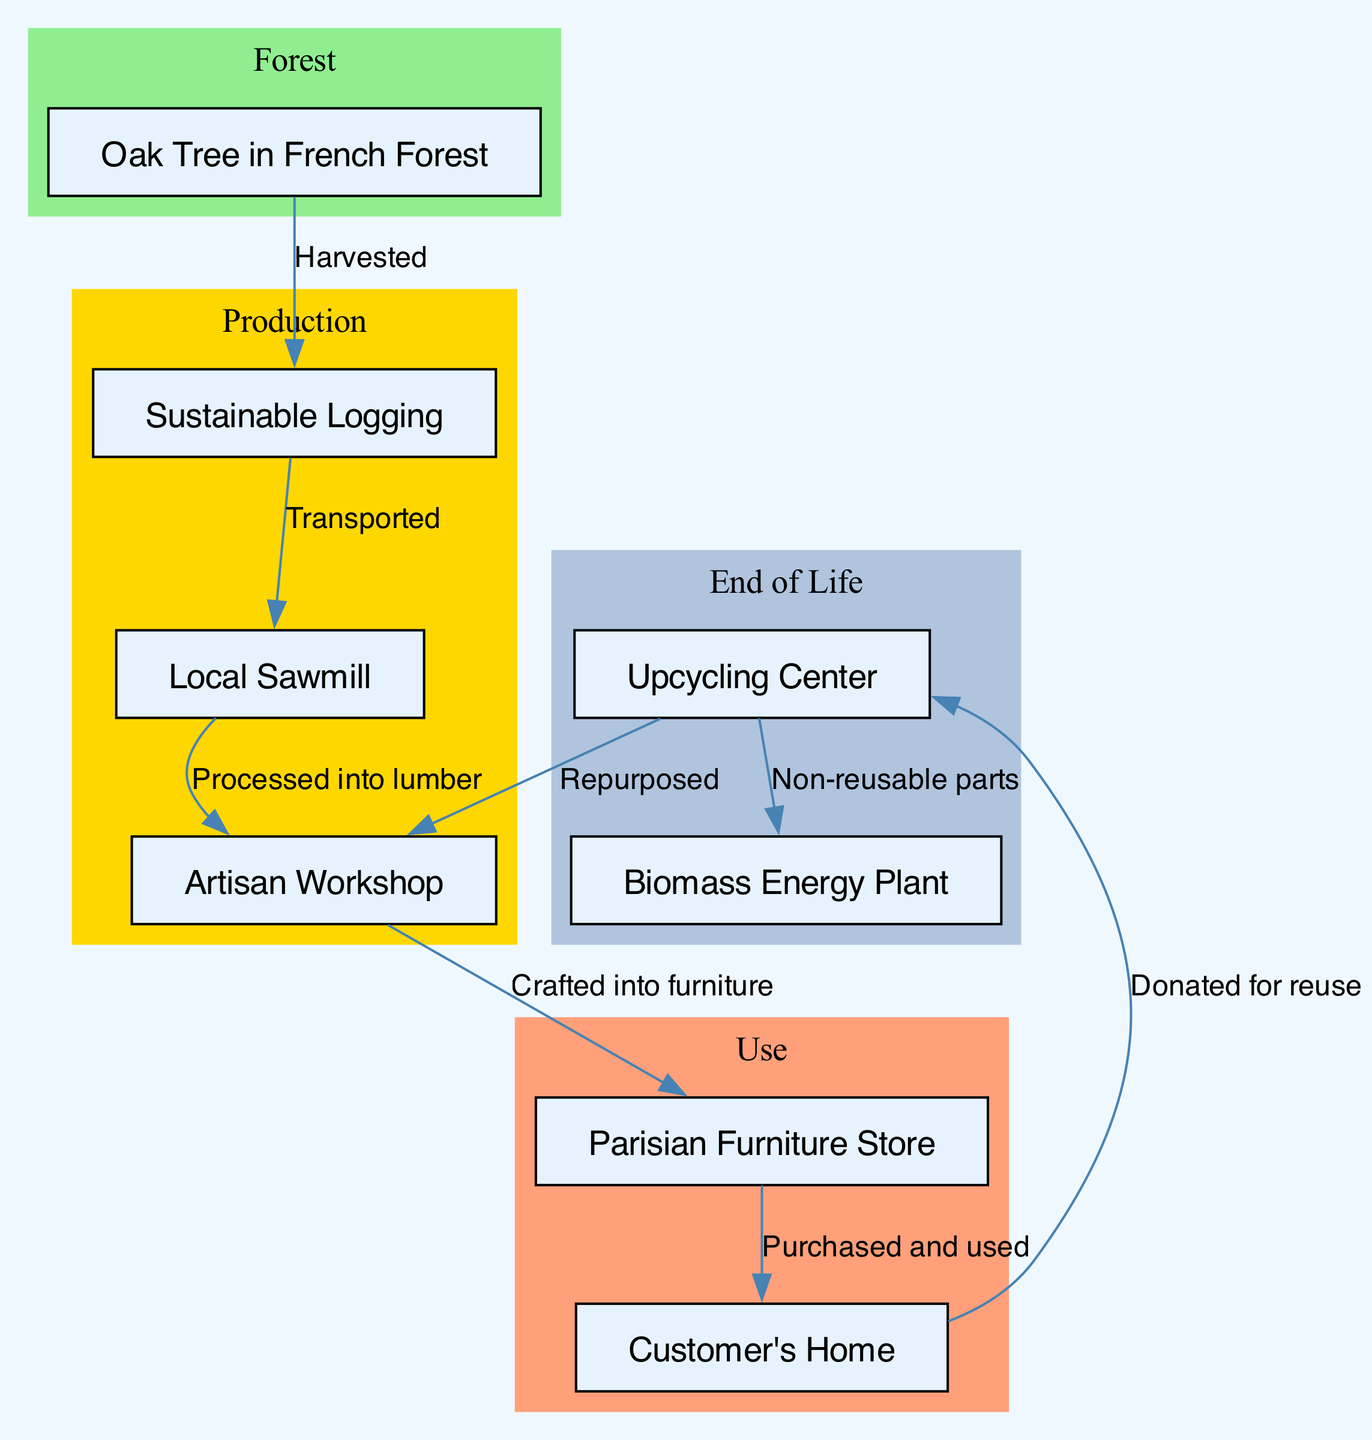What is the first step in the life cycle of wooden furniture? The life cycle begins with the "Oak Tree in French Forest," which represents the raw material source for the process.
Answer: Oak Tree in French Forest How many nodes are present in the diagram? By counting all the unique entities represented in the diagram, there are a total of eight nodes.
Answer: 8 What comes after "Local Sawmill"? The next step after "Local Sawmill" is "Artisan Workshop," where the processed lumber is crafted into furniture.
Answer: Artisan Workshop Which node represents the end-of-life stage for furniture? The end-of-life stage is represented by two nodes, "Upcycling Center" and "Biomass Energy Plant," indicating the possible disposal or repurposing of furniture.
Answer: Upcycling Center and Biomass Energy Plant What is the label for the edge coming from "Sustainable Logging" to "Local Sawmill"? The label for the edge indicates the action taken at that stage, which is "Transported," describing the movement of lumber to the sawmill.
Answer: Transported How does furniture reach the customer's home? The furniture is "Purchased and used" after it has been crafted in the Artisan Workshop and is then sold in the Parisian Furniture Store.
Answer: Purchased and used What happens to non-reusable parts of furniture? Non-reusable parts are sent to the "Biomass Energy Plant," indicating waste processing as part of the end-of-life transformation.
Answer: Biomass Energy Plant What does "Donated for reuse" imply about the furniture's life? The phrase indicates that the furniture, after its use in the customer's home, is given away for repurposing and not discarded immediately.
Answer: Donated for reuse 